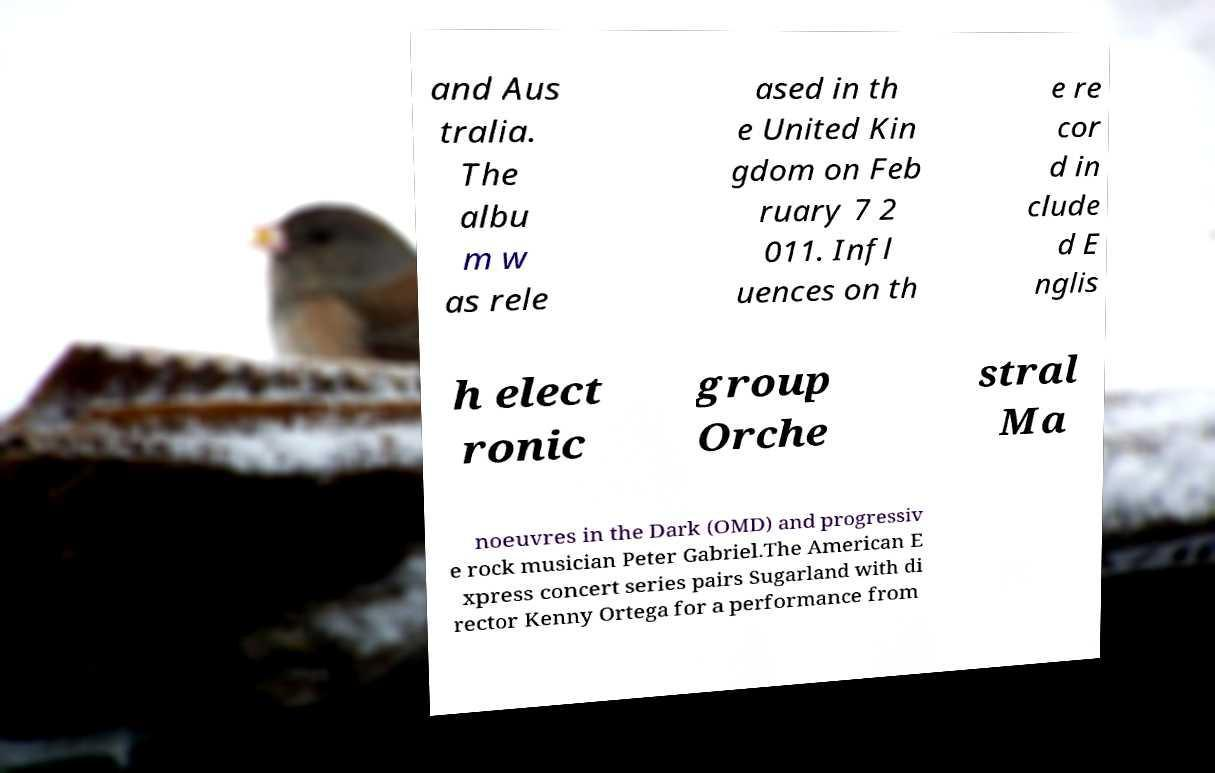What messages or text are displayed in this image? I need them in a readable, typed format. and Aus tralia. The albu m w as rele ased in th e United Kin gdom on Feb ruary 7 2 011. Infl uences on th e re cor d in clude d E nglis h elect ronic group Orche stral Ma noeuvres in the Dark (OMD) and progressiv e rock musician Peter Gabriel.The American E xpress concert series pairs Sugarland with di rector Kenny Ortega for a performance from 